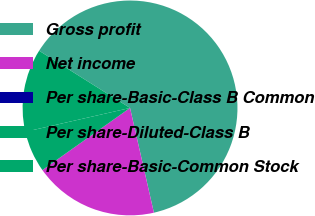Convert chart to OTSL. <chart><loc_0><loc_0><loc_500><loc_500><pie_chart><fcel>Gross profit<fcel>Net income<fcel>Per share-Basic-Class B Common<fcel>Per share-Diluted-Class B<fcel>Per share-Basic-Common Stock<nl><fcel>62.5%<fcel>18.75%<fcel>0.0%<fcel>6.25%<fcel>12.5%<nl></chart> 